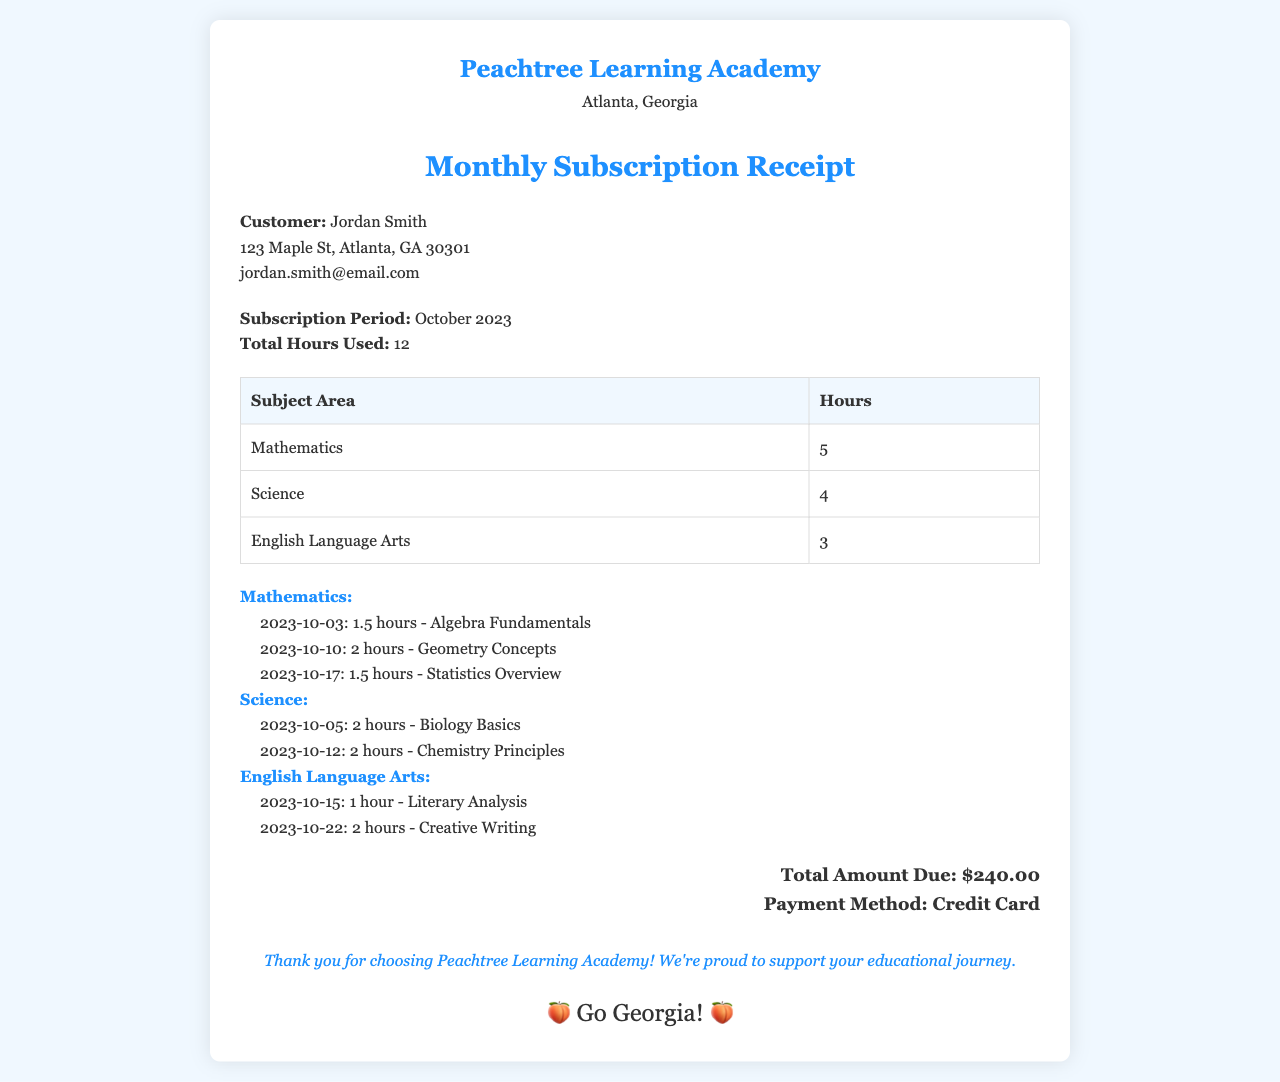What is the name of the customer? The customer's name is clearly stated under the customer details section.
Answer: Jordan Smith What is the total hours used in October 2023? The total hours used for the subscription period of October 2023 is specified in the subscription details section.
Answer: 12 How many hours were used for Mathematics? The hours dedicated to Mathematics can be found in the table listing subject areas and hours.
Answer: 5 What is the total amount due? The total amount due is mentioned at the end of the receipt, summarizing the charges for the month.
Answer: $240.00 On what date did the session for Biology Basics occur? The specific date for the Biology session is provided in the session details under the Science subject area.
Answer: 2023-10-05 Which subject area had the most hours used? By reviewing the hours listed in the table, we can determine which subject area was utilized the most.
Answer: Mathematics What payment method was used? The payment method is stated clearly in the total section of the receipt.
Answer: Credit Card How many hours were spent on English Language Arts? The corresponding hours for English Language Arts are listed in the subject area table.
Answer: 3 What session topic was covered on October 15, 2023? The specific session topic for that date is detailed in the session breakdown under English Language Arts.
Answer: Literary Analysis 